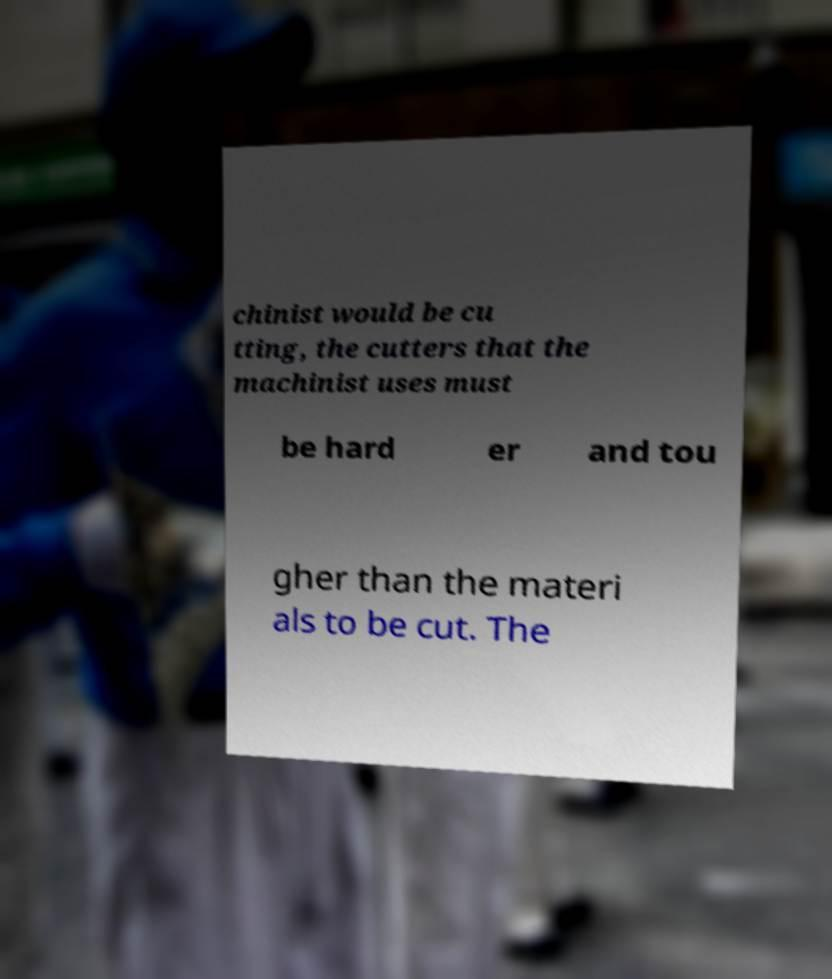Can you accurately transcribe the text from the provided image for me? chinist would be cu tting, the cutters that the machinist uses must be hard er and tou gher than the materi als to be cut. The 